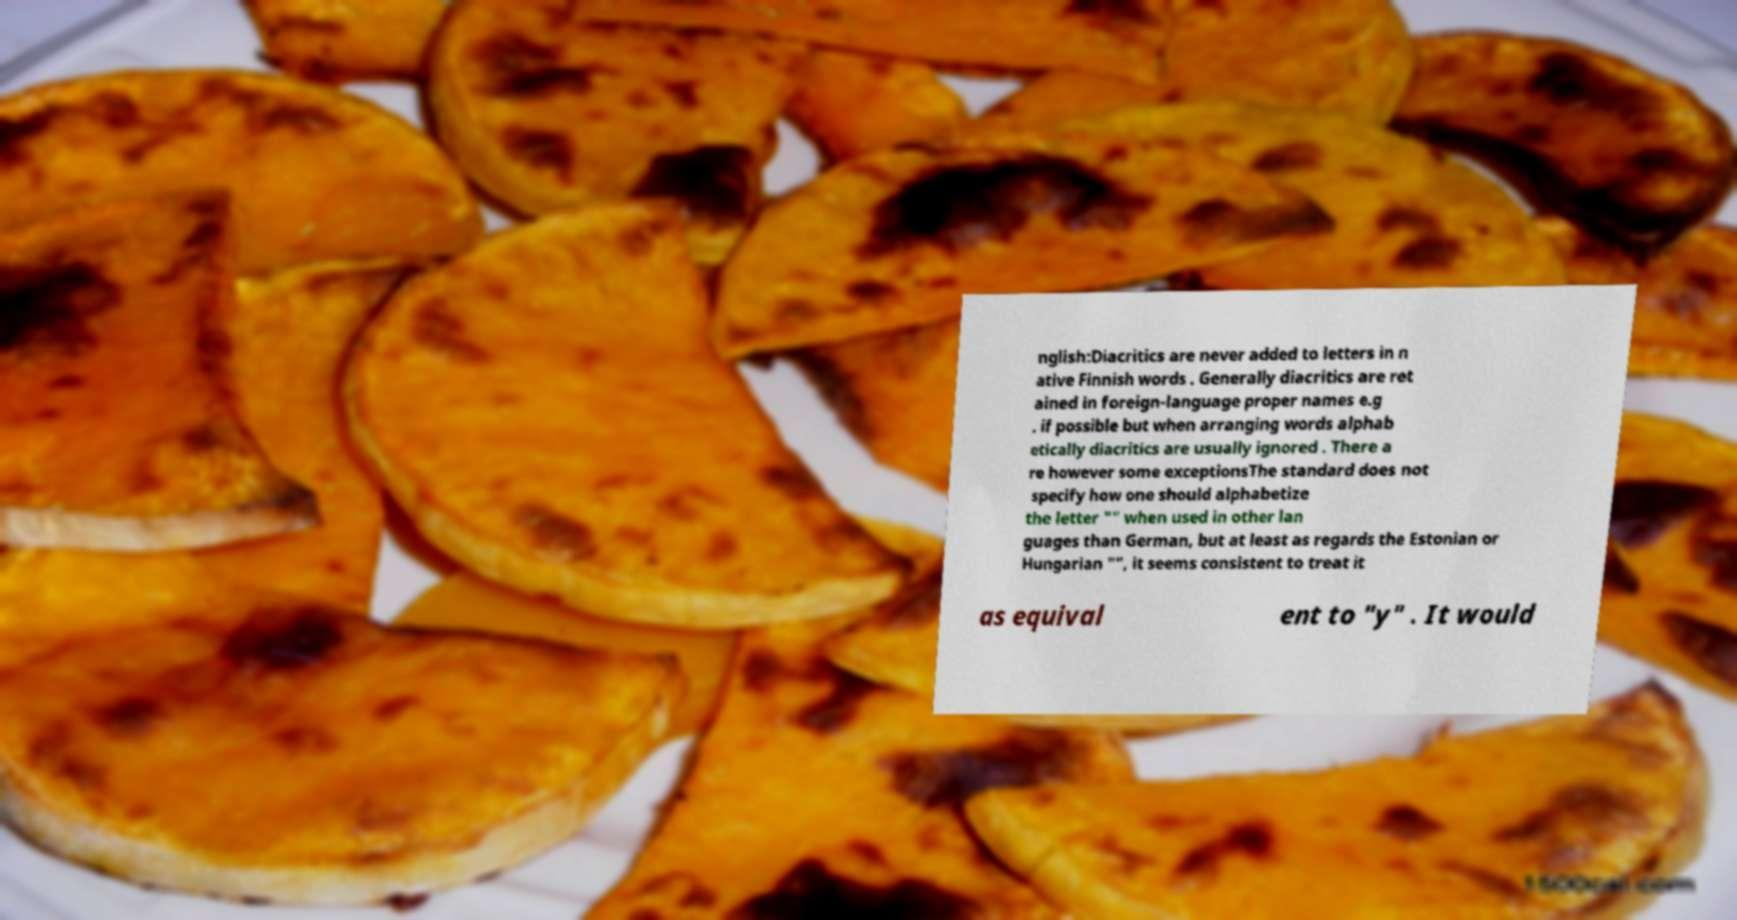Can you read and provide the text displayed in the image?This photo seems to have some interesting text. Can you extract and type it out for me? nglish:Diacritics are never added to letters in n ative Finnish words . Generally diacritics are ret ained in foreign-language proper names e.g . if possible but when arranging words alphab etically diacritics are usually ignored . There a re however some exceptionsThe standard does not specify how one should alphabetize the letter "" when used in other lan guages than German, but at least as regards the Estonian or Hungarian "", it seems consistent to treat it as equival ent to "y" . It would 